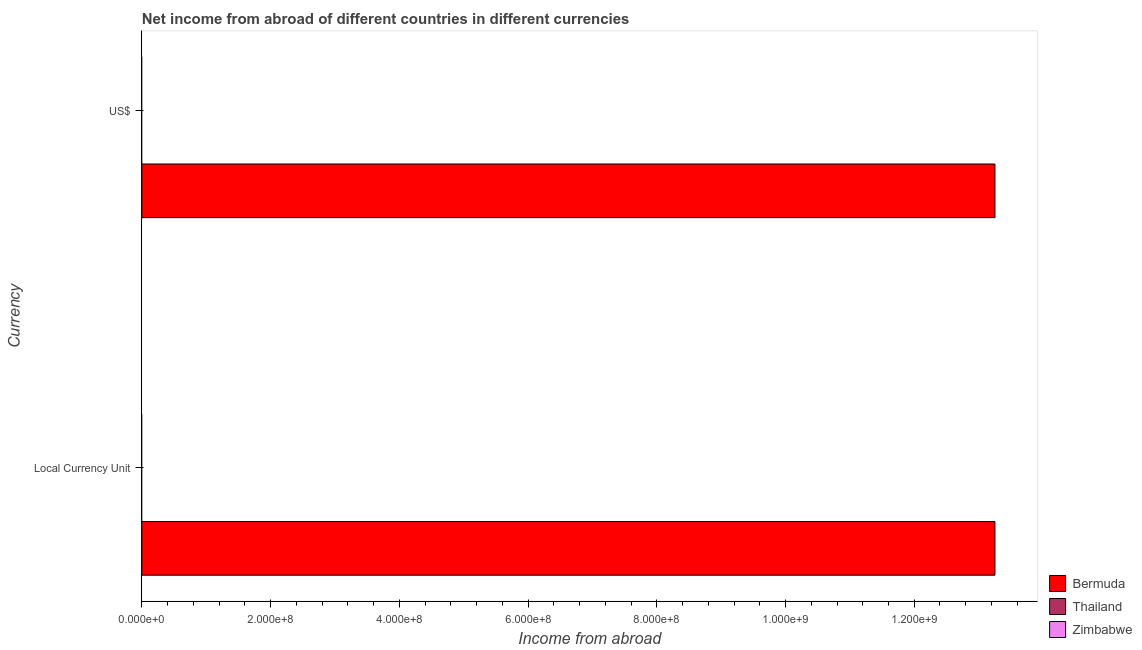How many different coloured bars are there?
Make the answer very short. 1. Are the number of bars per tick equal to the number of legend labels?
Offer a very short reply. No. How many bars are there on the 1st tick from the top?
Keep it short and to the point. 1. How many bars are there on the 1st tick from the bottom?
Your answer should be very brief. 1. What is the label of the 1st group of bars from the top?
Offer a very short reply. US$. What is the income from abroad in constant 2005 us$ in Thailand?
Your answer should be very brief. 0. Across all countries, what is the maximum income from abroad in constant 2005 us$?
Ensure brevity in your answer.  1.33e+09. Across all countries, what is the minimum income from abroad in constant 2005 us$?
Offer a very short reply. 0. In which country was the income from abroad in us$ maximum?
Give a very brief answer. Bermuda. What is the total income from abroad in us$ in the graph?
Make the answer very short. 1.33e+09. What is the average income from abroad in us$ per country?
Ensure brevity in your answer.  4.42e+08. What is the difference between the income from abroad in constant 2005 us$ and income from abroad in us$ in Bermuda?
Your response must be concise. 0. Are all the bars in the graph horizontal?
Keep it short and to the point. Yes. How many countries are there in the graph?
Keep it short and to the point. 3. Are the values on the major ticks of X-axis written in scientific E-notation?
Give a very brief answer. Yes. Does the graph contain any zero values?
Make the answer very short. Yes. How many legend labels are there?
Ensure brevity in your answer.  3. How are the legend labels stacked?
Your response must be concise. Vertical. What is the title of the graph?
Provide a succinct answer. Net income from abroad of different countries in different currencies. What is the label or title of the X-axis?
Offer a very short reply. Income from abroad. What is the label or title of the Y-axis?
Give a very brief answer. Currency. What is the Income from abroad in Bermuda in Local Currency Unit?
Offer a very short reply. 1.33e+09. What is the Income from abroad in Bermuda in US$?
Provide a succinct answer. 1.33e+09. What is the Income from abroad in Thailand in US$?
Ensure brevity in your answer.  0. Across all Currency, what is the maximum Income from abroad of Bermuda?
Offer a terse response. 1.33e+09. Across all Currency, what is the minimum Income from abroad in Bermuda?
Provide a succinct answer. 1.33e+09. What is the total Income from abroad in Bermuda in the graph?
Your answer should be very brief. 2.65e+09. What is the total Income from abroad of Thailand in the graph?
Keep it short and to the point. 0. What is the difference between the Income from abroad in Bermuda in Local Currency Unit and that in US$?
Your answer should be compact. 0. What is the average Income from abroad of Bermuda per Currency?
Your answer should be compact. 1.33e+09. What is the average Income from abroad of Thailand per Currency?
Provide a short and direct response. 0. What is the difference between the highest and the second highest Income from abroad in Bermuda?
Offer a terse response. 0. What is the difference between the highest and the lowest Income from abroad of Bermuda?
Make the answer very short. 0. 